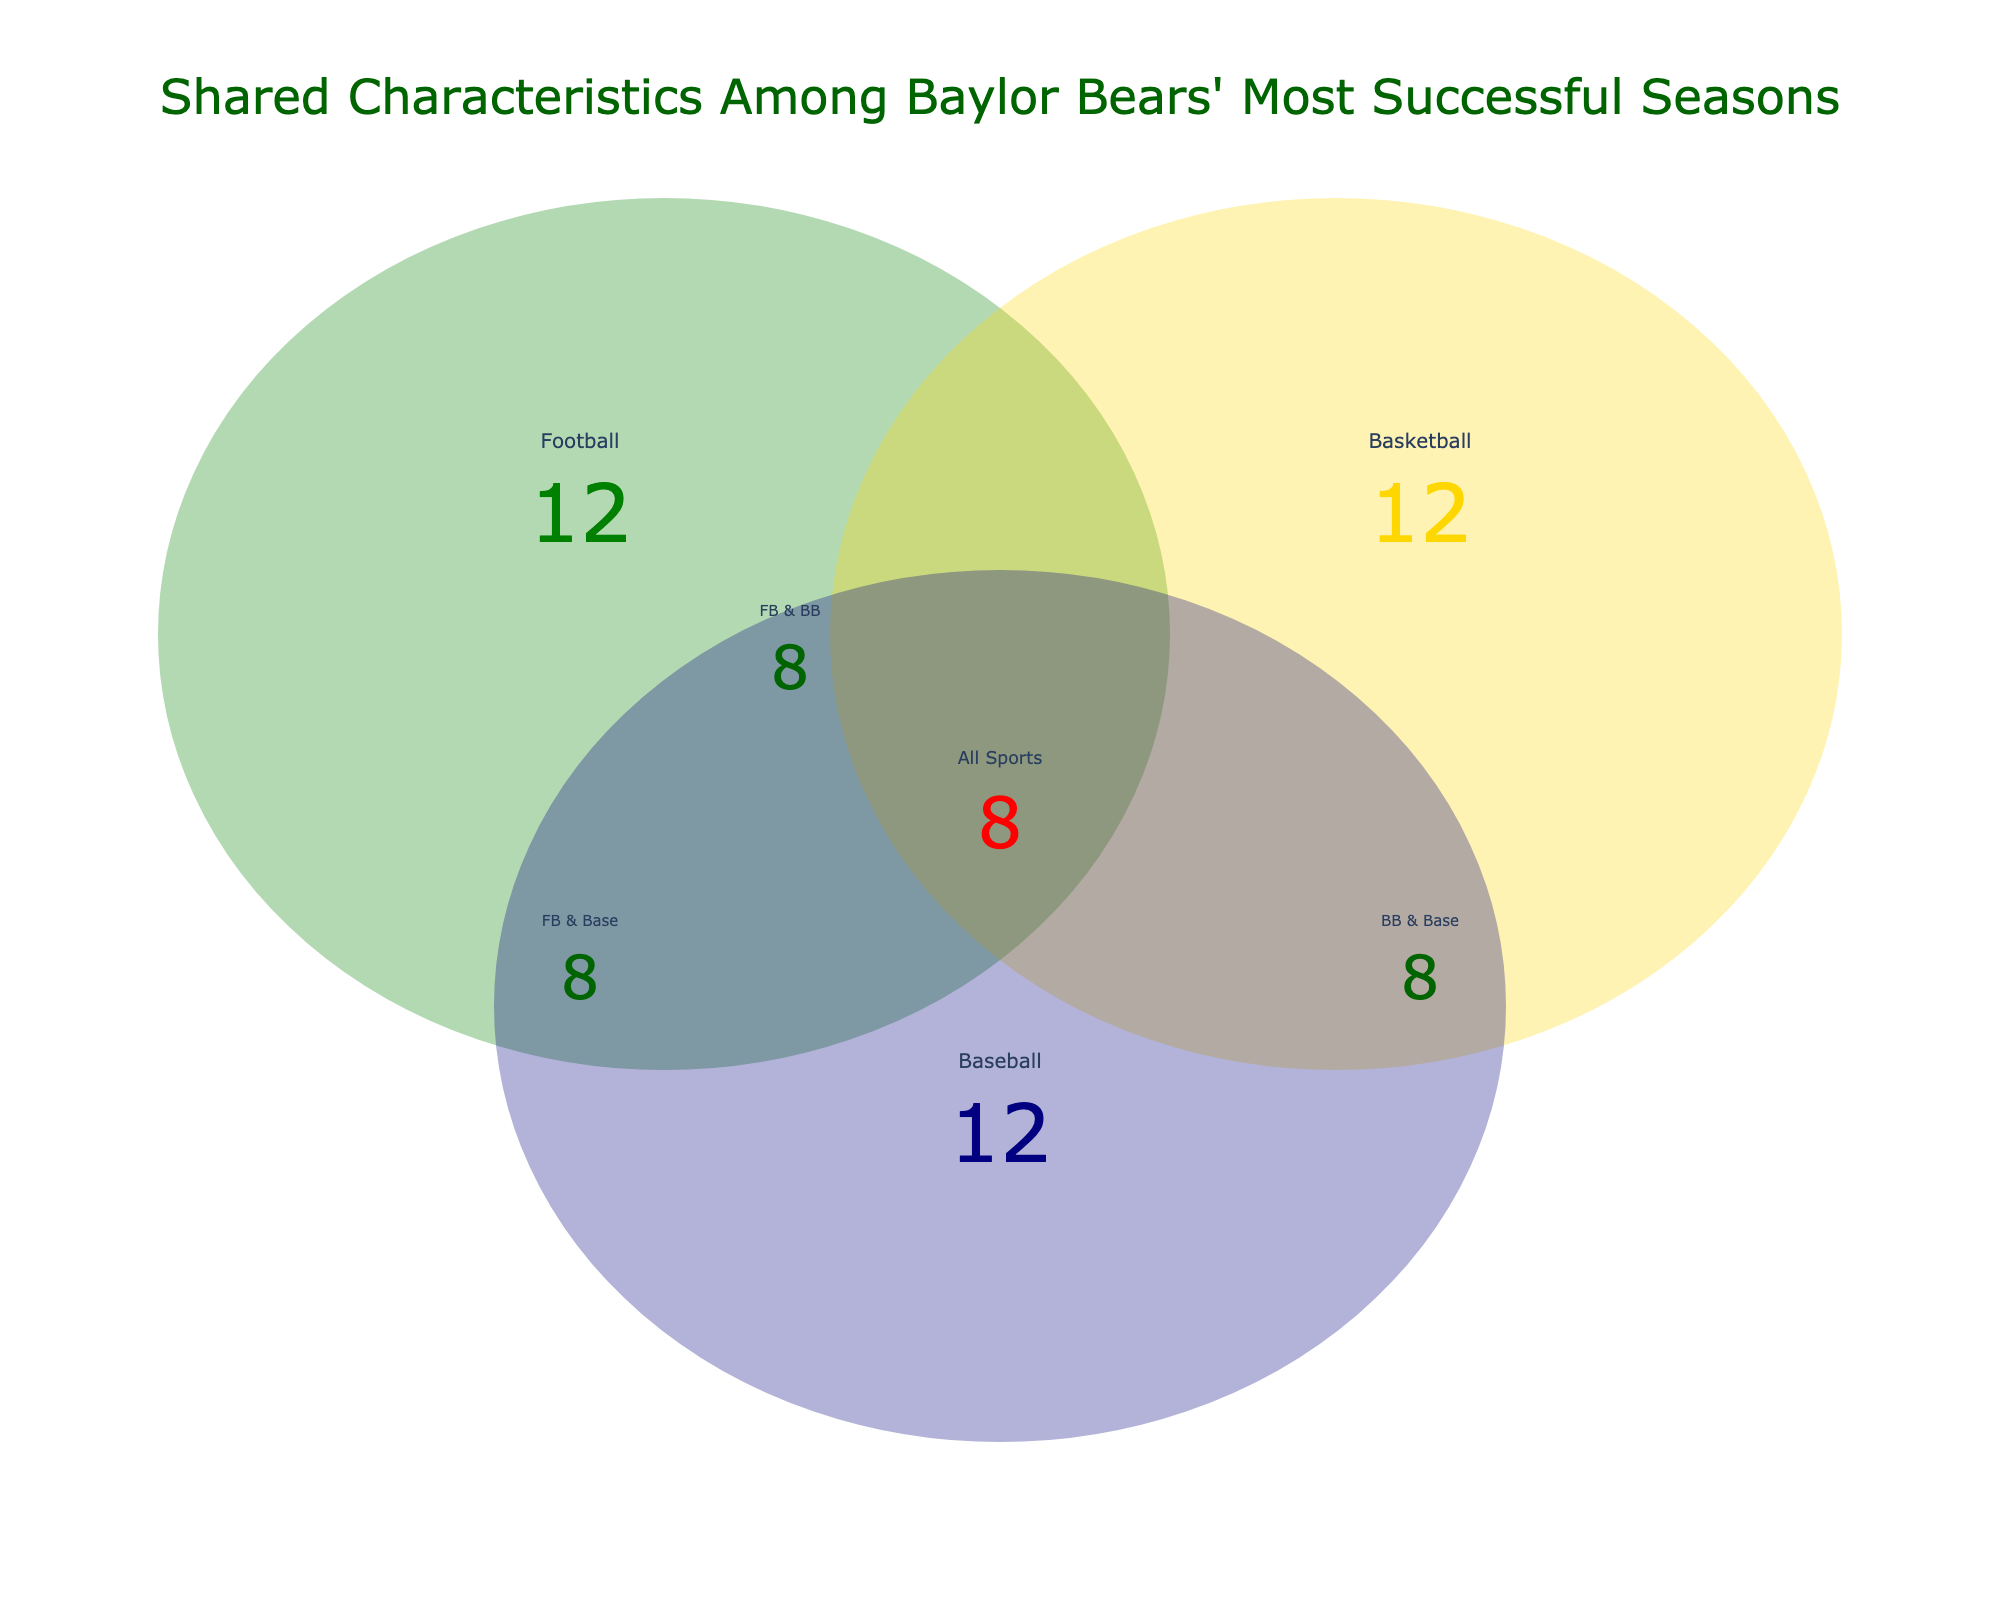What is the total number of shared characteristics among all three sports? Count the shared characteristics indicated in the section titled "All Sports." These include Big 12 Conference titles, National rankings, Fan attendance, Coaching stability, All-American selections, Conference Player of the Year, Upset victories, and Winning streaks. There are 8 elements.
Answer: 8 Which sport has the most unique characteristics not shared with the other two? Compare the number of unique characteristics for football, basketball, and baseball. Football's unique characteristics include Strong defense, Home field advantage, NFL draft picks, and Bowl game appearances (4). Basketball's unique characteristics include High scoring offense, Tournament success, and NBA draft picks (3). Baseball's unique characteristics include Strong pitching staff, Regular season dominance, and MLB draft picks (3). Thus, football has the most.
Answer: Football Which pairs of sports share the most characteristics? Compare the number of shared characteristics between Football & Basketball, Football & Baseball, and Basketball & Baseball. Football & Basketball share 7 characteristics, Football & Baseball share 7 characteristics, and Basketball & Baseball share 7 characteristics. The number is equal across all pairs.
Answer: All pairs equally How many characteristics are shared between Football and Basketball but not Baseball? Identify the shared characteristics between Football and Basketball, which are Big 12 Conference titles, National rankings, Fan attendance, Coaching stability, All-American selections, Conference Player of the Year, and Upset victories, and subtract those that are in all three sports. The ones not in Baseball from this group are NFL draft picks and Bowl game appearances, making a total of 2.
Answer: 2 What is the count of unique characteristics for Baseball that are not shared with Football or Basketball? Count the unique characteristics listed only under Baseball (excluding shared ones). Characteristics are Strong pitching staff, Regular season dominance, and MLB draft picks, so 3 in total.
Answer: 3 What common characteristic exists between Football and Baseball but is absent in Basketball? Identify shared characteristics between Football and Baseball, compare with Basketball, and extract the unique one. There is none, as all shared characteristics between Football and Baseball are also shared with Basketball.
Answer: None What is the color associated with the Football's unique characteristics section in the plot? Refer to the visualization's color coding. Football's unique section is colored in green.
Answer: Green Can you identify a characteristic shared across all sports that also specifically includes draft picks for each sport? Identify characteristics shared across Football, Basketball, and Baseball that specifically include draft picks, such as NFL draft picks, NBA draft picks, and MLB draft picks.
Answer: No Which characteristic is unique to Basketball alone? Compare Basketball's characteristics with those of Football and Baseball. High scoring offense, Tournament success, and NBA draft picks are unique to Basketball.
Answer: High scoring offense, Tournament success, NBA draft picks 